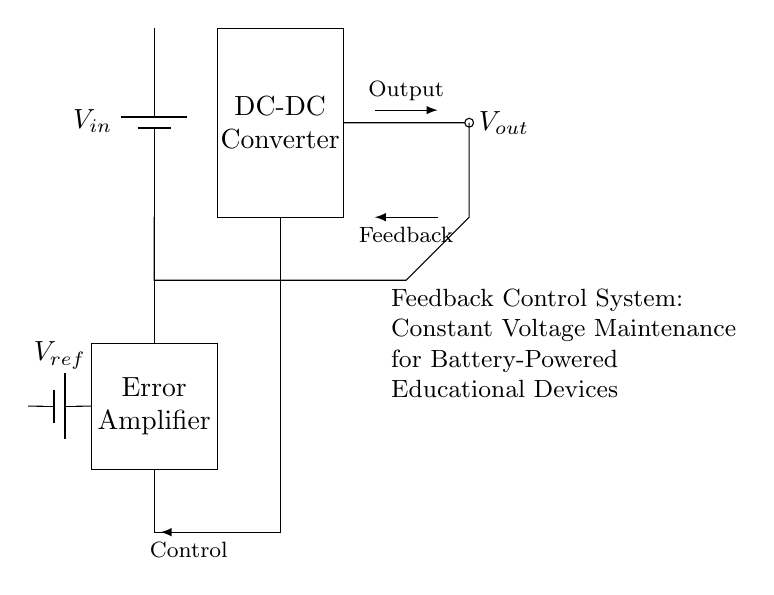What is the type of the main power source in the circuit? The main power source labeled as \( V_{in} \) is a battery, indicated by the symbol and representation in the circuit.
Answer: Battery What does \( V_{ref} \) represent in the circuit? \( V_{ref} \) is a reference voltage provided by another battery in the feedback control system, crucial for the error amplifier to compare the output voltage against.
Answer: Reference voltage How is the output voltage described in this circuit? The output voltage \( V_{out} \) is generated by the DC-DC converter, which is shown as the component after the battery. It's the voltage being controlled and fed back for regulation.
Answer: Controlled output voltage What is the role of the error amplifier in this circuit? The error amplifier processes the difference between the reference voltage \( V_{ref} \) and the actual output voltage \( V_{out} \) to produce a control signal that ensures the output voltage stays constant.
Answer: Control signal generator What feedback mechanism is used in this control system? The feedback mechanism is a negative feedback loop connecting the output back to the input of the error amplifier, allowing for continuous regulation of the output voltage.
Answer: Negative feedback What happens to the output if \( V_{in} \) decreases? If \( V_{in} \) decreases, the DC-DC converter will adjust its output voltage to maintain \( V_{out} \) through the error amplifier's feedback control mechanism.
Answer: Output adjustment How does the feedback connection influence the system stability? The feedback connection stabilizes the system by continually adjusting the output based on the difference between \( V_{out} \) and \( V_{ref} \), ensuring that any deviations are corrected promptly.
Answer: Enhances stability 